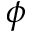Convert formula to latex. <formula><loc_0><loc_0><loc_500><loc_500>\phi</formula> 